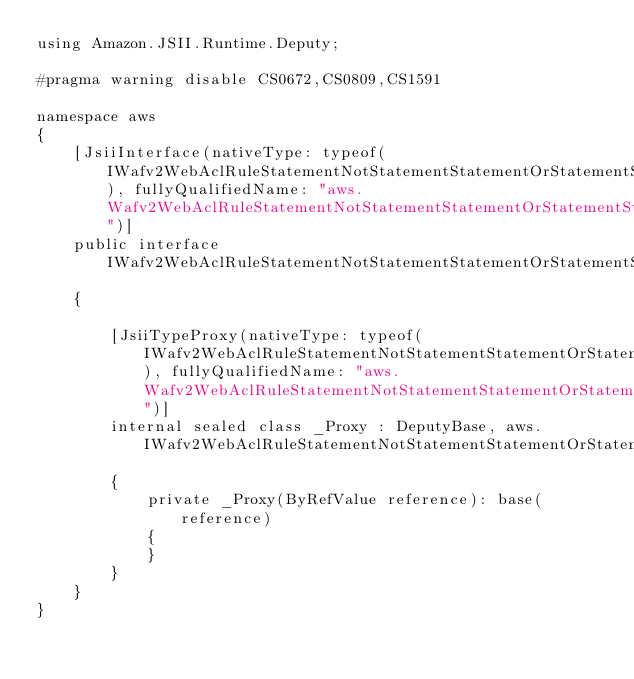<code> <loc_0><loc_0><loc_500><loc_500><_C#_>using Amazon.JSII.Runtime.Deputy;

#pragma warning disable CS0672,CS0809,CS1591

namespace aws
{
    [JsiiInterface(nativeType: typeof(IWafv2WebAclRuleStatementNotStatementStatementOrStatementStatementByteMatchStatementFieldToMatchMethod), fullyQualifiedName: "aws.Wafv2WebAclRuleStatementNotStatementStatementOrStatementStatementByteMatchStatementFieldToMatchMethod")]
    public interface IWafv2WebAclRuleStatementNotStatementStatementOrStatementStatementByteMatchStatementFieldToMatchMethod
    {

        [JsiiTypeProxy(nativeType: typeof(IWafv2WebAclRuleStatementNotStatementStatementOrStatementStatementByteMatchStatementFieldToMatchMethod), fullyQualifiedName: "aws.Wafv2WebAclRuleStatementNotStatementStatementOrStatementStatementByteMatchStatementFieldToMatchMethod")]
        internal sealed class _Proxy : DeputyBase, aws.IWafv2WebAclRuleStatementNotStatementStatementOrStatementStatementByteMatchStatementFieldToMatchMethod
        {
            private _Proxy(ByRefValue reference): base(reference)
            {
            }
        }
    }
}
</code> 